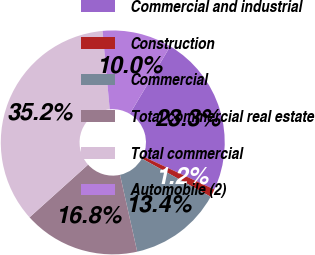<chart> <loc_0><loc_0><loc_500><loc_500><pie_chart><fcel>Commercial and industrial<fcel>Construction<fcel>Commercial<fcel>Total commercial real estate<fcel>Total commercial<fcel>Automobile (2)<nl><fcel>23.33%<fcel>1.16%<fcel>13.43%<fcel>16.84%<fcel>35.21%<fcel>10.03%<nl></chart> 